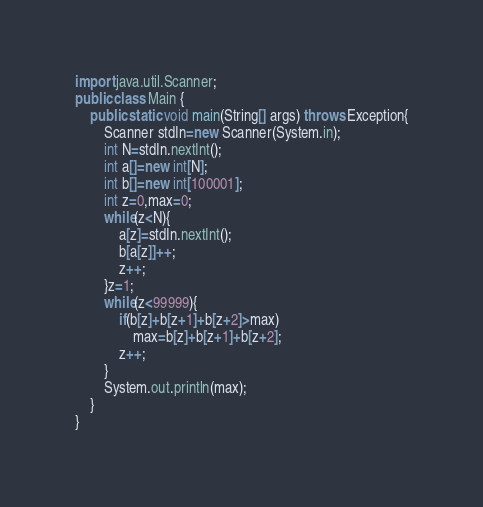Convert code to text. <code><loc_0><loc_0><loc_500><loc_500><_Java_>import java.util.Scanner;
public class Main {
	public static void main(String[] args) throws Exception{
		Scanner stdIn=new Scanner(System.in);
		int N=stdIn.nextInt();
		int a[]=new int[N];
		int b[]=new int[100001];
		int z=0,max=0;
		while(z<N){
			a[z]=stdIn.nextInt();
			b[a[z]]++;
			z++;
		}z=1;
		while(z<99999){
			if(b[z]+b[z+1]+b[z+2]>max)
				max=b[z]+b[z+1]+b[z+2];
			z++;
		}
		System.out.println(max);
	}
}</code> 